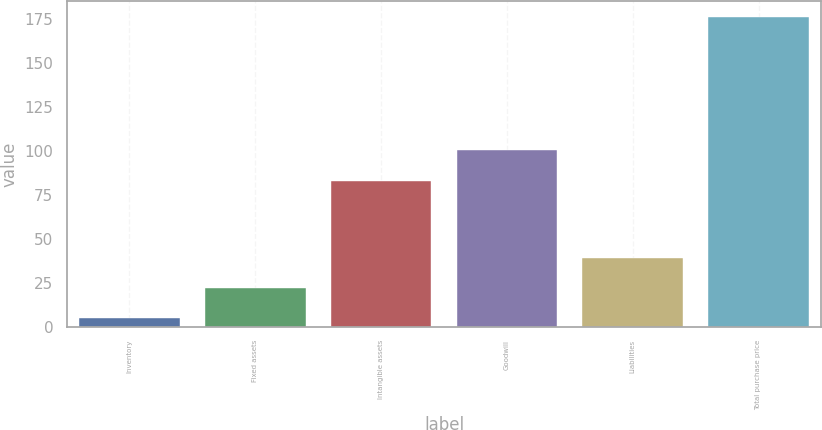Convert chart to OTSL. <chart><loc_0><loc_0><loc_500><loc_500><bar_chart><fcel>Inventory<fcel>Fixed assets<fcel>Intangible assets<fcel>Goodwill<fcel>Liabilities<fcel>Total purchase price<nl><fcel>5<fcel>22.1<fcel>83<fcel>100.1<fcel>39.2<fcel>176<nl></chart> 